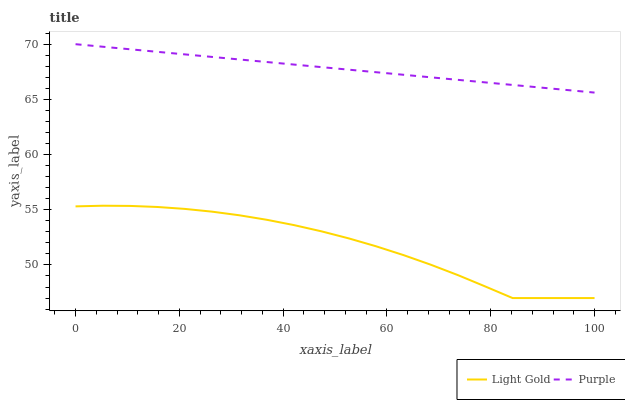Does Light Gold have the minimum area under the curve?
Answer yes or no. Yes. Does Purple have the maximum area under the curve?
Answer yes or no. Yes. Does Light Gold have the maximum area under the curve?
Answer yes or no. No. Is Purple the smoothest?
Answer yes or no. Yes. Is Light Gold the roughest?
Answer yes or no. Yes. Is Light Gold the smoothest?
Answer yes or no. No. Does Light Gold have the lowest value?
Answer yes or no. Yes. Does Purple have the highest value?
Answer yes or no. Yes. Does Light Gold have the highest value?
Answer yes or no. No. Is Light Gold less than Purple?
Answer yes or no. Yes. Is Purple greater than Light Gold?
Answer yes or no. Yes. Does Light Gold intersect Purple?
Answer yes or no. No. 